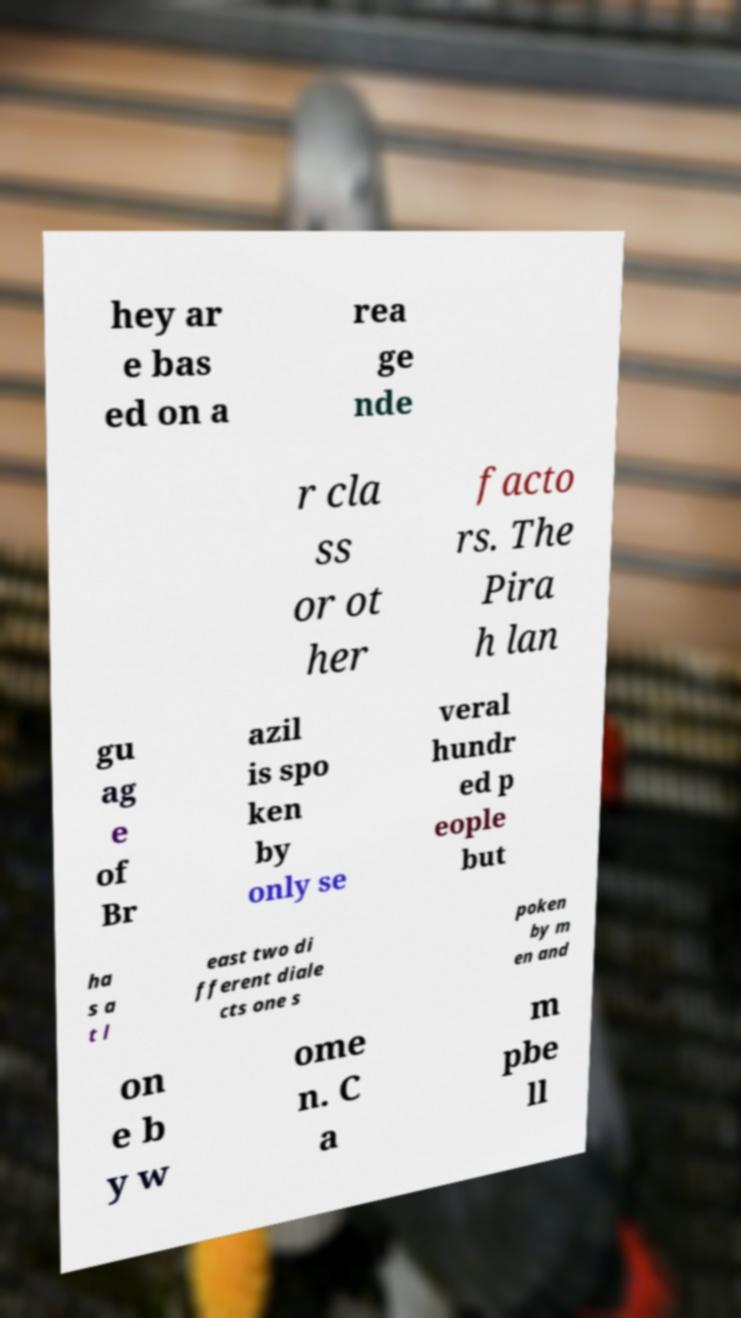There's text embedded in this image that I need extracted. Can you transcribe it verbatim? hey ar e bas ed on a rea ge nde r cla ss or ot her facto rs. The Pira h lan gu ag e of Br azil is spo ken by only se veral hundr ed p eople but ha s a t l east two di fferent diale cts one s poken by m en and on e b y w ome n. C a m pbe ll 